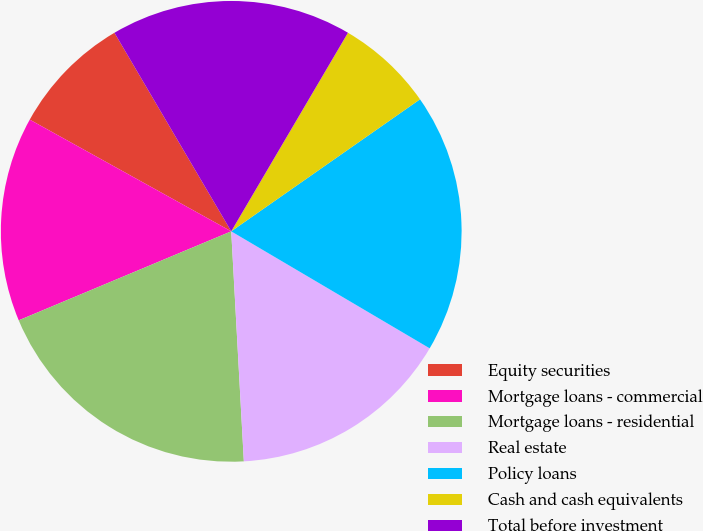Convert chart to OTSL. <chart><loc_0><loc_0><loc_500><loc_500><pie_chart><fcel>Equity securities<fcel>Mortgage loans - commercial<fcel>Mortgage loans - residential<fcel>Real estate<fcel>Policy loans<fcel>Cash and cash equivalents<fcel>Total before investment<nl><fcel>8.48%<fcel>14.37%<fcel>19.56%<fcel>15.65%<fcel>18.19%<fcel>6.83%<fcel>16.92%<nl></chart> 